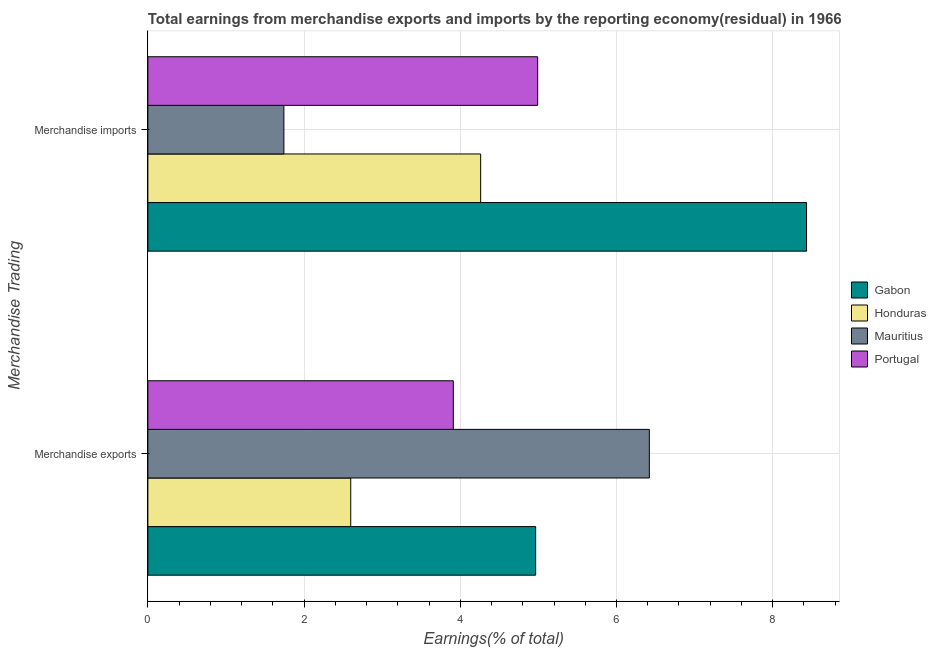How many different coloured bars are there?
Make the answer very short. 4. Are the number of bars per tick equal to the number of legend labels?
Give a very brief answer. Yes. Are the number of bars on each tick of the Y-axis equal?
Keep it short and to the point. Yes. What is the earnings from merchandise imports in Mauritius?
Provide a short and direct response. 1.74. Across all countries, what is the maximum earnings from merchandise imports?
Provide a short and direct response. 8.43. Across all countries, what is the minimum earnings from merchandise imports?
Make the answer very short. 1.74. In which country was the earnings from merchandise imports maximum?
Provide a succinct answer. Gabon. In which country was the earnings from merchandise imports minimum?
Offer a very short reply. Mauritius. What is the total earnings from merchandise exports in the graph?
Keep it short and to the point. 17.89. What is the difference between the earnings from merchandise imports in Honduras and that in Gabon?
Your response must be concise. -4.17. What is the difference between the earnings from merchandise exports in Honduras and the earnings from merchandise imports in Gabon?
Provide a short and direct response. -5.84. What is the average earnings from merchandise exports per country?
Make the answer very short. 4.47. What is the difference between the earnings from merchandise imports and earnings from merchandise exports in Gabon?
Provide a short and direct response. 3.47. What is the ratio of the earnings from merchandise exports in Portugal to that in Mauritius?
Ensure brevity in your answer.  0.61. In how many countries, is the earnings from merchandise exports greater than the average earnings from merchandise exports taken over all countries?
Make the answer very short. 2. What does the 3rd bar from the top in Merchandise exports represents?
Your response must be concise. Honduras. Are the values on the major ticks of X-axis written in scientific E-notation?
Keep it short and to the point. No. Does the graph contain grids?
Offer a terse response. Yes. Where does the legend appear in the graph?
Give a very brief answer. Center right. How are the legend labels stacked?
Make the answer very short. Vertical. What is the title of the graph?
Give a very brief answer. Total earnings from merchandise exports and imports by the reporting economy(residual) in 1966. Does "Lebanon" appear as one of the legend labels in the graph?
Make the answer very short. No. What is the label or title of the X-axis?
Give a very brief answer. Earnings(% of total). What is the label or title of the Y-axis?
Give a very brief answer. Merchandise Trading. What is the Earnings(% of total) in Gabon in Merchandise exports?
Offer a very short reply. 4.97. What is the Earnings(% of total) in Honduras in Merchandise exports?
Your answer should be very brief. 2.6. What is the Earnings(% of total) in Mauritius in Merchandise exports?
Offer a very short reply. 6.42. What is the Earnings(% of total) of Portugal in Merchandise exports?
Keep it short and to the point. 3.91. What is the Earnings(% of total) of Gabon in Merchandise imports?
Offer a terse response. 8.43. What is the Earnings(% of total) in Honduras in Merchandise imports?
Your answer should be compact. 4.26. What is the Earnings(% of total) in Mauritius in Merchandise imports?
Keep it short and to the point. 1.74. What is the Earnings(% of total) of Portugal in Merchandise imports?
Your response must be concise. 4.99. Across all Merchandise Trading, what is the maximum Earnings(% of total) in Gabon?
Offer a very short reply. 8.43. Across all Merchandise Trading, what is the maximum Earnings(% of total) in Honduras?
Offer a terse response. 4.26. Across all Merchandise Trading, what is the maximum Earnings(% of total) of Mauritius?
Provide a succinct answer. 6.42. Across all Merchandise Trading, what is the maximum Earnings(% of total) in Portugal?
Provide a short and direct response. 4.99. Across all Merchandise Trading, what is the minimum Earnings(% of total) of Gabon?
Offer a very short reply. 4.97. Across all Merchandise Trading, what is the minimum Earnings(% of total) in Honduras?
Offer a terse response. 2.6. Across all Merchandise Trading, what is the minimum Earnings(% of total) of Mauritius?
Ensure brevity in your answer.  1.74. Across all Merchandise Trading, what is the minimum Earnings(% of total) in Portugal?
Your answer should be very brief. 3.91. What is the total Earnings(% of total) of Gabon in the graph?
Your response must be concise. 13.4. What is the total Earnings(% of total) of Honduras in the graph?
Your answer should be very brief. 6.86. What is the total Earnings(% of total) of Mauritius in the graph?
Your answer should be compact. 8.16. What is the total Earnings(% of total) of Portugal in the graph?
Offer a terse response. 8.9. What is the difference between the Earnings(% of total) of Gabon in Merchandise exports and that in Merchandise imports?
Ensure brevity in your answer.  -3.47. What is the difference between the Earnings(% of total) in Honduras in Merchandise exports and that in Merchandise imports?
Give a very brief answer. -1.66. What is the difference between the Earnings(% of total) of Mauritius in Merchandise exports and that in Merchandise imports?
Your answer should be compact. 4.68. What is the difference between the Earnings(% of total) of Portugal in Merchandise exports and that in Merchandise imports?
Your answer should be compact. -1.08. What is the difference between the Earnings(% of total) of Gabon in Merchandise exports and the Earnings(% of total) of Honduras in Merchandise imports?
Give a very brief answer. 0.7. What is the difference between the Earnings(% of total) in Gabon in Merchandise exports and the Earnings(% of total) in Mauritius in Merchandise imports?
Your response must be concise. 3.22. What is the difference between the Earnings(% of total) of Gabon in Merchandise exports and the Earnings(% of total) of Portugal in Merchandise imports?
Offer a terse response. -0.03. What is the difference between the Earnings(% of total) of Honduras in Merchandise exports and the Earnings(% of total) of Mauritius in Merchandise imports?
Your answer should be compact. 0.86. What is the difference between the Earnings(% of total) of Honduras in Merchandise exports and the Earnings(% of total) of Portugal in Merchandise imports?
Ensure brevity in your answer.  -2.39. What is the difference between the Earnings(% of total) in Mauritius in Merchandise exports and the Earnings(% of total) in Portugal in Merchandise imports?
Your response must be concise. 1.43. What is the average Earnings(% of total) in Gabon per Merchandise Trading?
Offer a very short reply. 6.7. What is the average Earnings(% of total) in Honduras per Merchandise Trading?
Your answer should be very brief. 3.43. What is the average Earnings(% of total) in Mauritius per Merchandise Trading?
Your answer should be compact. 4.08. What is the average Earnings(% of total) in Portugal per Merchandise Trading?
Ensure brevity in your answer.  4.45. What is the difference between the Earnings(% of total) of Gabon and Earnings(% of total) of Honduras in Merchandise exports?
Ensure brevity in your answer.  2.37. What is the difference between the Earnings(% of total) in Gabon and Earnings(% of total) in Mauritius in Merchandise exports?
Give a very brief answer. -1.46. What is the difference between the Earnings(% of total) of Gabon and Earnings(% of total) of Portugal in Merchandise exports?
Your answer should be compact. 1.05. What is the difference between the Earnings(% of total) of Honduras and Earnings(% of total) of Mauritius in Merchandise exports?
Provide a short and direct response. -3.82. What is the difference between the Earnings(% of total) of Honduras and Earnings(% of total) of Portugal in Merchandise exports?
Ensure brevity in your answer.  -1.31. What is the difference between the Earnings(% of total) in Mauritius and Earnings(% of total) in Portugal in Merchandise exports?
Your answer should be very brief. 2.51. What is the difference between the Earnings(% of total) of Gabon and Earnings(% of total) of Honduras in Merchandise imports?
Your answer should be very brief. 4.17. What is the difference between the Earnings(% of total) in Gabon and Earnings(% of total) in Mauritius in Merchandise imports?
Give a very brief answer. 6.69. What is the difference between the Earnings(% of total) of Gabon and Earnings(% of total) of Portugal in Merchandise imports?
Your answer should be very brief. 3.44. What is the difference between the Earnings(% of total) in Honduras and Earnings(% of total) in Mauritius in Merchandise imports?
Your answer should be very brief. 2.52. What is the difference between the Earnings(% of total) of Honduras and Earnings(% of total) of Portugal in Merchandise imports?
Offer a very short reply. -0.73. What is the difference between the Earnings(% of total) in Mauritius and Earnings(% of total) in Portugal in Merchandise imports?
Your answer should be very brief. -3.25. What is the ratio of the Earnings(% of total) of Gabon in Merchandise exports to that in Merchandise imports?
Offer a very short reply. 0.59. What is the ratio of the Earnings(% of total) in Honduras in Merchandise exports to that in Merchandise imports?
Provide a short and direct response. 0.61. What is the ratio of the Earnings(% of total) of Mauritius in Merchandise exports to that in Merchandise imports?
Provide a short and direct response. 3.69. What is the ratio of the Earnings(% of total) of Portugal in Merchandise exports to that in Merchandise imports?
Your response must be concise. 0.78. What is the difference between the highest and the second highest Earnings(% of total) in Gabon?
Offer a very short reply. 3.47. What is the difference between the highest and the second highest Earnings(% of total) in Honduras?
Provide a succinct answer. 1.66. What is the difference between the highest and the second highest Earnings(% of total) of Mauritius?
Your response must be concise. 4.68. What is the difference between the highest and the second highest Earnings(% of total) of Portugal?
Make the answer very short. 1.08. What is the difference between the highest and the lowest Earnings(% of total) in Gabon?
Provide a succinct answer. 3.47. What is the difference between the highest and the lowest Earnings(% of total) in Honduras?
Keep it short and to the point. 1.66. What is the difference between the highest and the lowest Earnings(% of total) of Mauritius?
Offer a terse response. 4.68. What is the difference between the highest and the lowest Earnings(% of total) in Portugal?
Give a very brief answer. 1.08. 